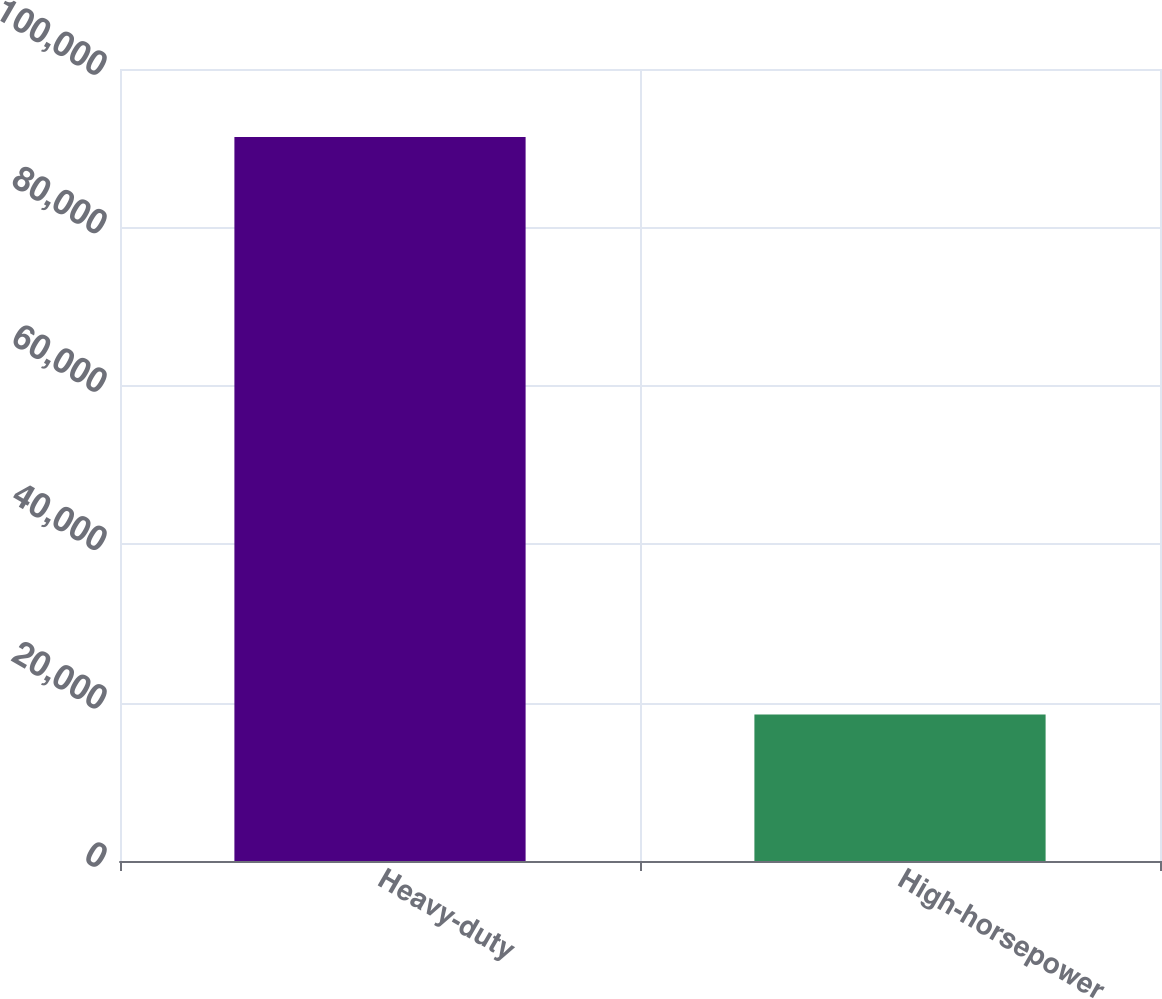Convert chart. <chart><loc_0><loc_0><loc_500><loc_500><bar_chart><fcel>Heavy-duty<fcel>High-horsepower<nl><fcel>91400<fcel>18500<nl></chart> 